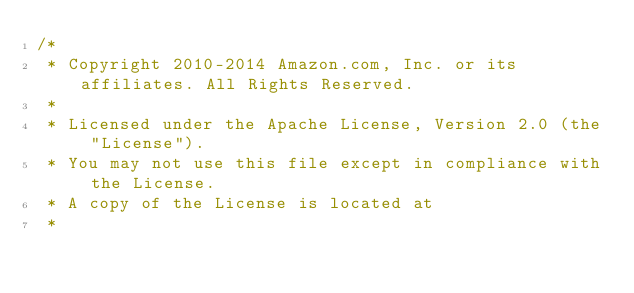Convert code to text. <code><loc_0><loc_0><loc_500><loc_500><_C#_>/*
 * Copyright 2010-2014 Amazon.com, Inc. or its affiliates. All Rights Reserved.
 * 
 * Licensed under the Apache License, Version 2.0 (the "License").
 * You may not use this file except in compliance with the License.
 * A copy of the License is located at
 * </code> 